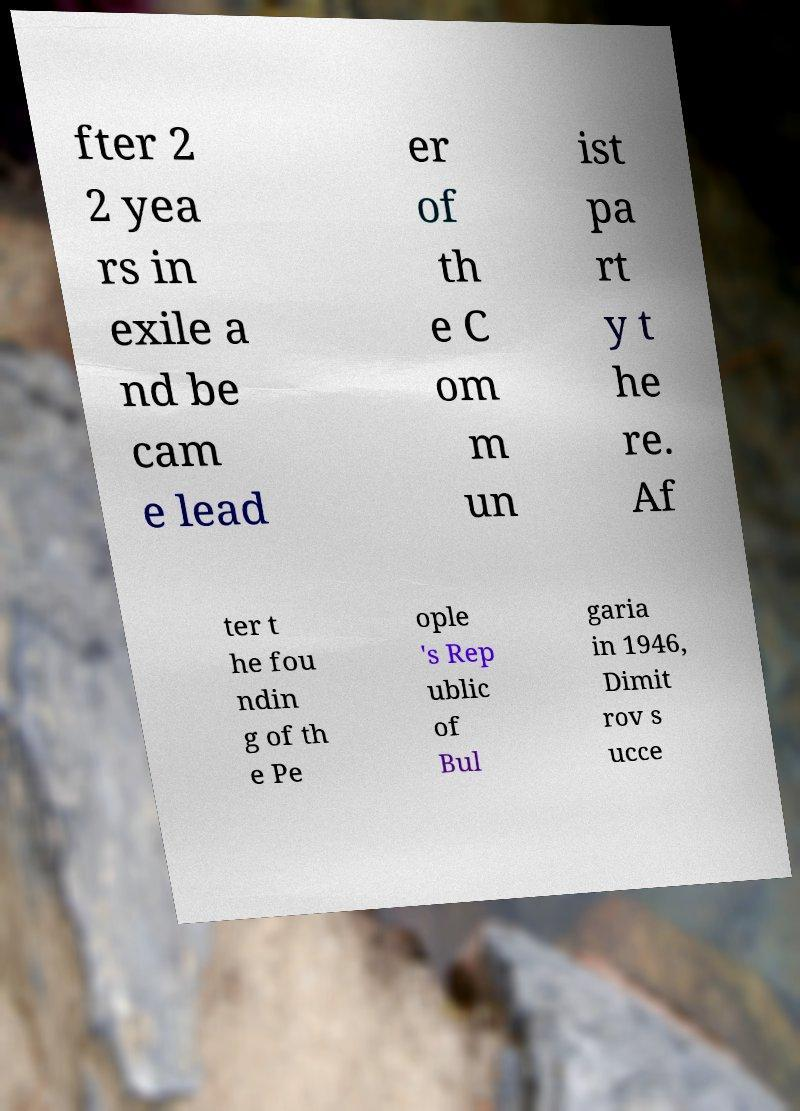For documentation purposes, I need the text within this image transcribed. Could you provide that? fter 2 2 yea rs in exile a nd be cam e lead er of th e C om m un ist pa rt y t he re. Af ter t he fou ndin g of th e Pe ople 's Rep ublic of Bul garia in 1946, Dimit rov s ucce 